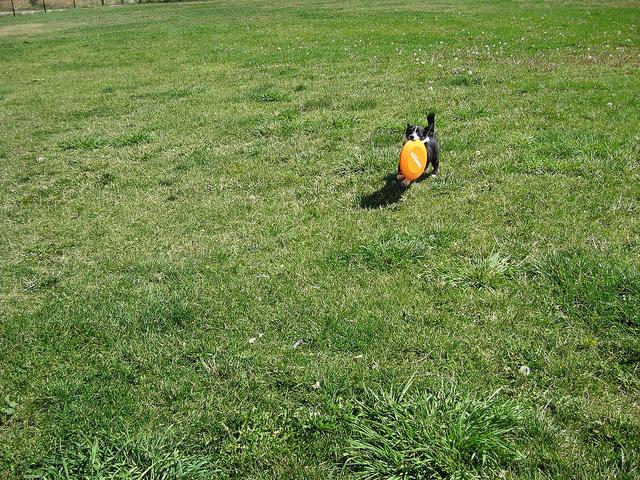Do you see houses?
Write a very short answer. No. What kind of dog is carrying the frisbee?
Give a very brief answer. Terrier. How old is the dog?
Be succinct. 2. What is this dog carrying?
Be succinct. Frisbee. 